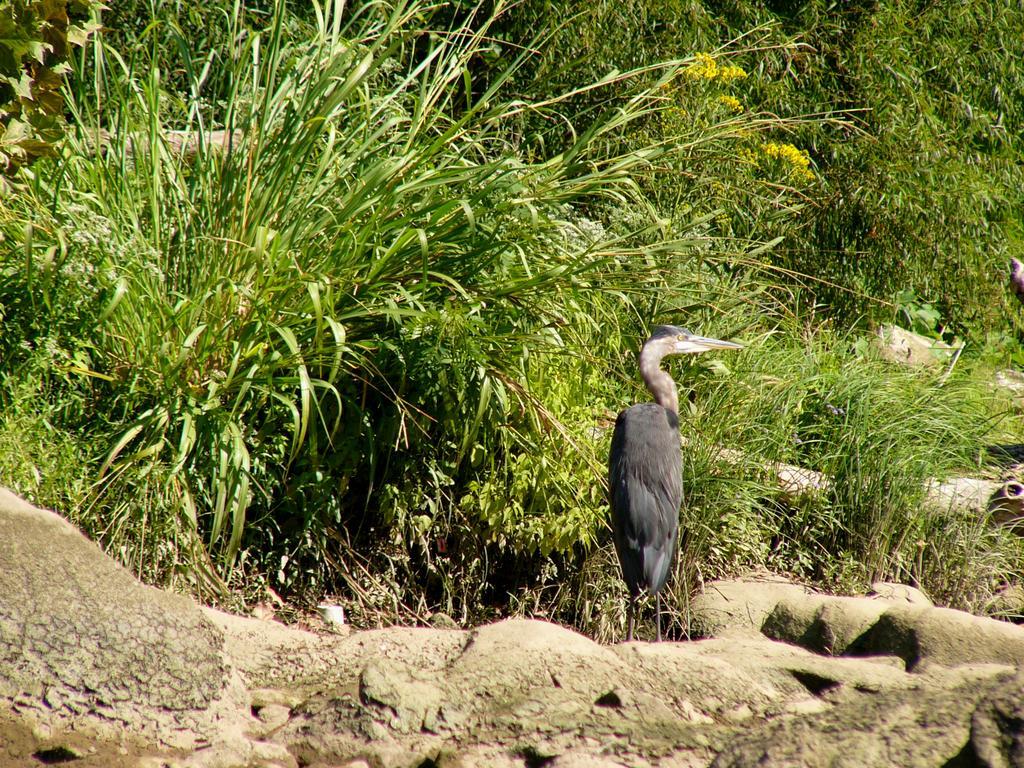Can you describe this image briefly? In this image we can see a bird is standing on the rocky surface. Background of the image grass and plants are there. 